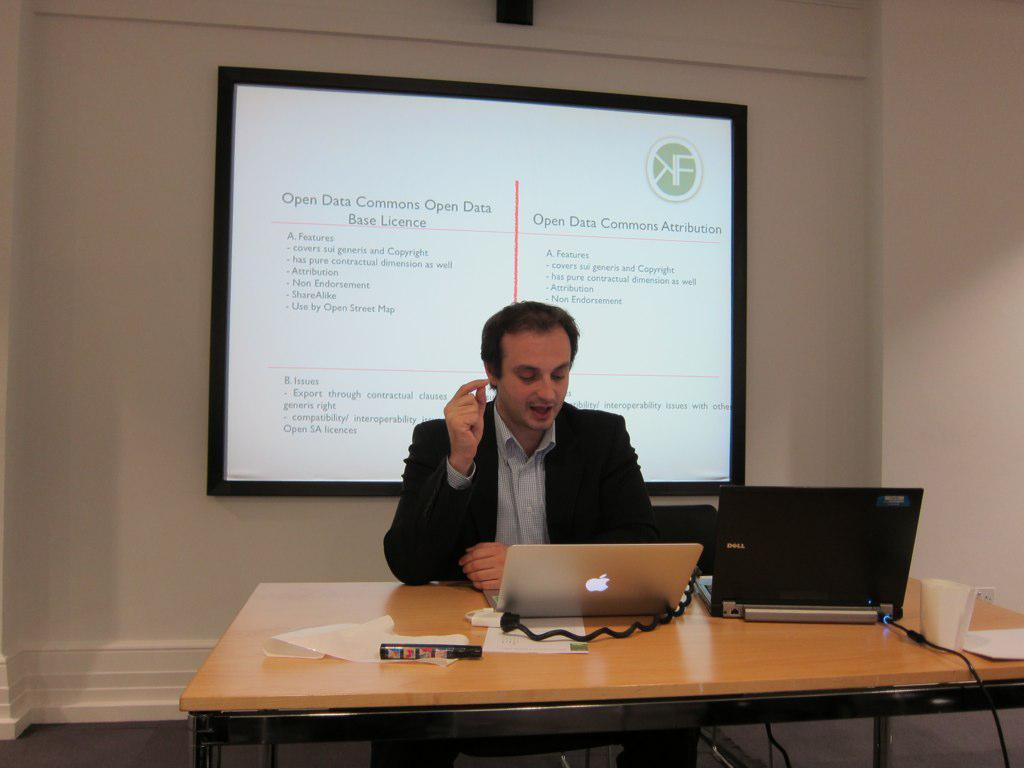What is the person in the image doing? The person is sitting on a chair in the image. What is located on the table in the image? There are two laptops, a glass, a paper, and a sketch on the table in the image. Can you describe the background of the image? There is a wall and a projector visible in the background. What type of cactus can be seen on the table in the image? There is no cactus present on the table in the image. What animal is interacting with the sketch on the table? There is no animal present in the image, and the sketch is not being interacted with by any creature. 